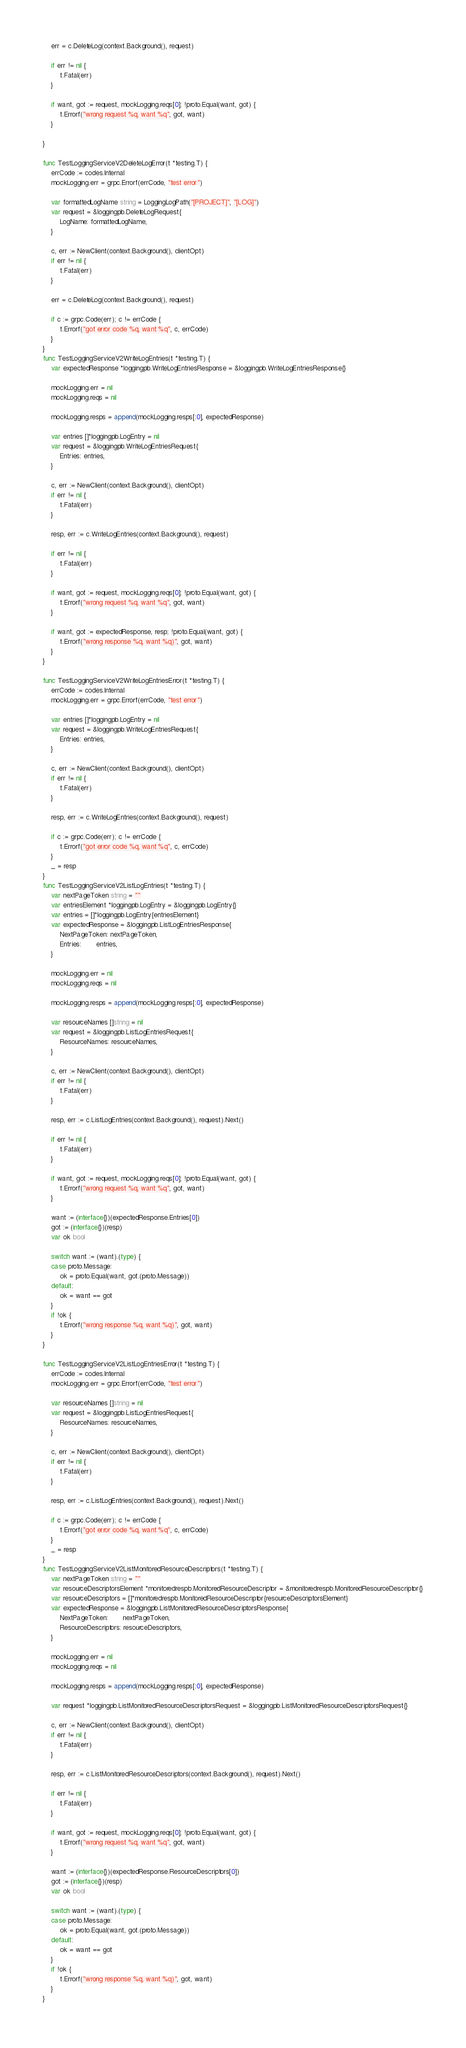<code> <loc_0><loc_0><loc_500><loc_500><_Go_>
	err = c.DeleteLog(context.Background(), request)

	if err != nil {
		t.Fatal(err)
	}

	if want, got := request, mockLogging.reqs[0]; !proto.Equal(want, got) {
		t.Errorf("wrong request %q, want %q", got, want)
	}

}

func TestLoggingServiceV2DeleteLogError(t *testing.T) {
	errCode := codes.Internal
	mockLogging.err = grpc.Errorf(errCode, "test error")

	var formattedLogName string = LoggingLogPath("[PROJECT]", "[LOG]")
	var request = &loggingpb.DeleteLogRequest{
		LogName: formattedLogName,
	}

	c, err := NewClient(context.Background(), clientOpt)
	if err != nil {
		t.Fatal(err)
	}

	err = c.DeleteLog(context.Background(), request)

	if c := grpc.Code(err); c != errCode {
		t.Errorf("got error code %q, want %q", c, errCode)
	}
}
func TestLoggingServiceV2WriteLogEntries(t *testing.T) {
	var expectedResponse *loggingpb.WriteLogEntriesResponse = &loggingpb.WriteLogEntriesResponse{}

	mockLogging.err = nil
	mockLogging.reqs = nil

	mockLogging.resps = append(mockLogging.resps[:0], expectedResponse)

	var entries []*loggingpb.LogEntry = nil
	var request = &loggingpb.WriteLogEntriesRequest{
		Entries: entries,
	}

	c, err := NewClient(context.Background(), clientOpt)
	if err != nil {
		t.Fatal(err)
	}

	resp, err := c.WriteLogEntries(context.Background(), request)

	if err != nil {
		t.Fatal(err)
	}

	if want, got := request, mockLogging.reqs[0]; !proto.Equal(want, got) {
		t.Errorf("wrong request %q, want %q", got, want)
	}

	if want, got := expectedResponse, resp; !proto.Equal(want, got) {
		t.Errorf("wrong response %q, want %q)", got, want)
	}
}

func TestLoggingServiceV2WriteLogEntriesError(t *testing.T) {
	errCode := codes.Internal
	mockLogging.err = grpc.Errorf(errCode, "test error")

	var entries []*loggingpb.LogEntry = nil
	var request = &loggingpb.WriteLogEntriesRequest{
		Entries: entries,
	}

	c, err := NewClient(context.Background(), clientOpt)
	if err != nil {
		t.Fatal(err)
	}

	resp, err := c.WriteLogEntries(context.Background(), request)

	if c := grpc.Code(err); c != errCode {
		t.Errorf("got error code %q, want %q", c, errCode)
	}
	_ = resp
}
func TestLoggingServiceV2ListLogEntries(t *testing.T) {
	var nextPageToken string = ""
	var entriesElement *loggingpb.LogEntry = &loggingpb.LogEntry{}
	var entries = []*loggingpb.LogEntry{entriesElement}
	var expectedResponse = &loggingpb.ListLogEntriesResponse{
		NextPageToken: nextPageToken,
		Entries:       entries,
	}

	mockLogging.err = nil
	mockLogging.reqs = nil

	mockLogging.resps = append(mockLogging.resps[:0], expectedResponse)

	var resourceNames []string = nil
	var request = &loggingpb.ListLogEntriesRequest{
		ResourceNames: resourceNames,
	}

	c, err := NewClient(context.Background(), clientOpt)
	if err != nil {
		t.Fatal(err)
	}

	resp, err := c.ListLogEntries(context.Background(), request).Next()

	if err != nil {
		t.Fatal(err)
	}

	if want, got := request, mockLogging.reqs[0]; !proto.Equal(want, got) {
		t.Errorf("wrong request %q, want %q", got, want)
	}

	want := (interface{})(expectedResponse.Entries[0])
	got := (interface{})(resp)
	var ok bool

	switch want := (want).(type) {
	case proto.Message:
		ok = proto.Equal(want, got.(proto.Message))
	default:
		ok = want == got
	}
	if !ok {
		t.Errorf("wrong response %q, want %q)", got, want)
	}
}

func TestLoggingServiceV2ListLogEntriesError(t *testing.T) {
	errCode := codes.Internal
	mockLogging.err = grpc.Errorf(errCode, "test error")

	var resourceNames []string = nil
	var request = &loggingpb.ListLogEntriesRequest{
		ResourceNames: resourceNames,
	}

	c, err := NewClient(context.Background(), clientOpt)
	if err != nil {
		t.Fatal(err)
	}

	resp, err := c.ListLogEntries(context.Background(), request).Next()

	if c := grpc.Code(err); c != errCode {
		t.Errorf("got error code %q, want %q", c, errCode)
	}
	_ = resp
}
func TestLoggingServiceV2ListMonitoredResourceDescriptors(t *testing.T) {
	var nextPageToken string = ""
	var resourceDescriptorsElement *monitoredrespb.MonitoredResourceDescriptor = &monitoredrespb.MonitoredResourceDescriptor{}
	var resourceDescriptors = []*monitoredrespb.MonitoredResourceDescriptor{resourceDescriptorsElement}
	var expectedResponse = &loggingpb.ListMonitoredResourceDescriptorsResponse{
		NextPageToken:       nextPageToken,
		ResourceDescriptors: resourceDescriptors,
	}

	mockLogging.err = nil
	mockLogging.reqs = nil

	mockLogging.resps = append(mockLogging.resps[:0], expectedResponse)

	var request *loggingpb.ListMonitoredResourceDescriptorsRequest = &loggingpb.ListMonitoredResourceDescriptorsRequest{}

	c, err := NewClient(context.Background(), clientOpt)
	if err != nil {
		t.Fatal(err)
	}

	resp, err := c.ListMonitoredResourceDescriptors(context.Background(), request).Next()

	if err != nil {
		t.Fatal(err)
	}

	if want, got := request, mockLogging.reqs[0]; !proto.Equal(want, got) {
		t.Errorf("wrong request %q, want %q", got, want)
	}

	want := (interface{})(expectedResponse.ResourceDescriptors[0])
	got := (interface{})(resp)
	var ok bool

	switch want := (want).(type) {
	case proto.Message:
		ok = proto.Equal(want, got.(proto.Message))
	default:
		ok = want == got
	}
	if !ok {
		t.Errorf("wrong response %q, want %q)", got, want)
	}
}
</code> 